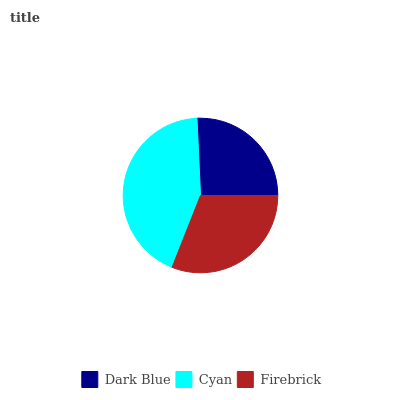Is Dark Blue the minimum?
Answer yes or no. Yes. Is Cyan the maximum?
Answer yes or no. Yes. Is Firebrick the minimum?
Answer yes or no. No. Is Firebrick the maximum?
Answer yes or no. No. Is Cyan greater than Firebrick?
Answer yes or no. Yes. Is Firebrick less than Cyan?
Answer yes or no. Yes. Is Firebrick greater than Cyan?
Answer yes or no. No. Is Cyan less than Firebrick?
Answer yes or no. No. Is Firebrick the high median?
Answer yes or no. Yes. Is Firebrick the low median?
Answer yes or no. Yes. Is Dark Blue the high median?
Answer yes or no. No. Is Dark Blue the low median?
Answer yes or no. No. 